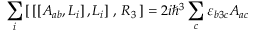<formula> <loc_0><loc_0><loc_500><loc_500>\sum _ { i } \left [ \, \left [ \left [ A _ { a b } , L _ { i } \right ] , L _ { i } \right ] \, , \, R _ { 3 } \, \right ] = 2 i \hbar { ^ } { 3 } \sum _ { c } \varepsilon _ { b 3 c } A _ { a c }</formula> 